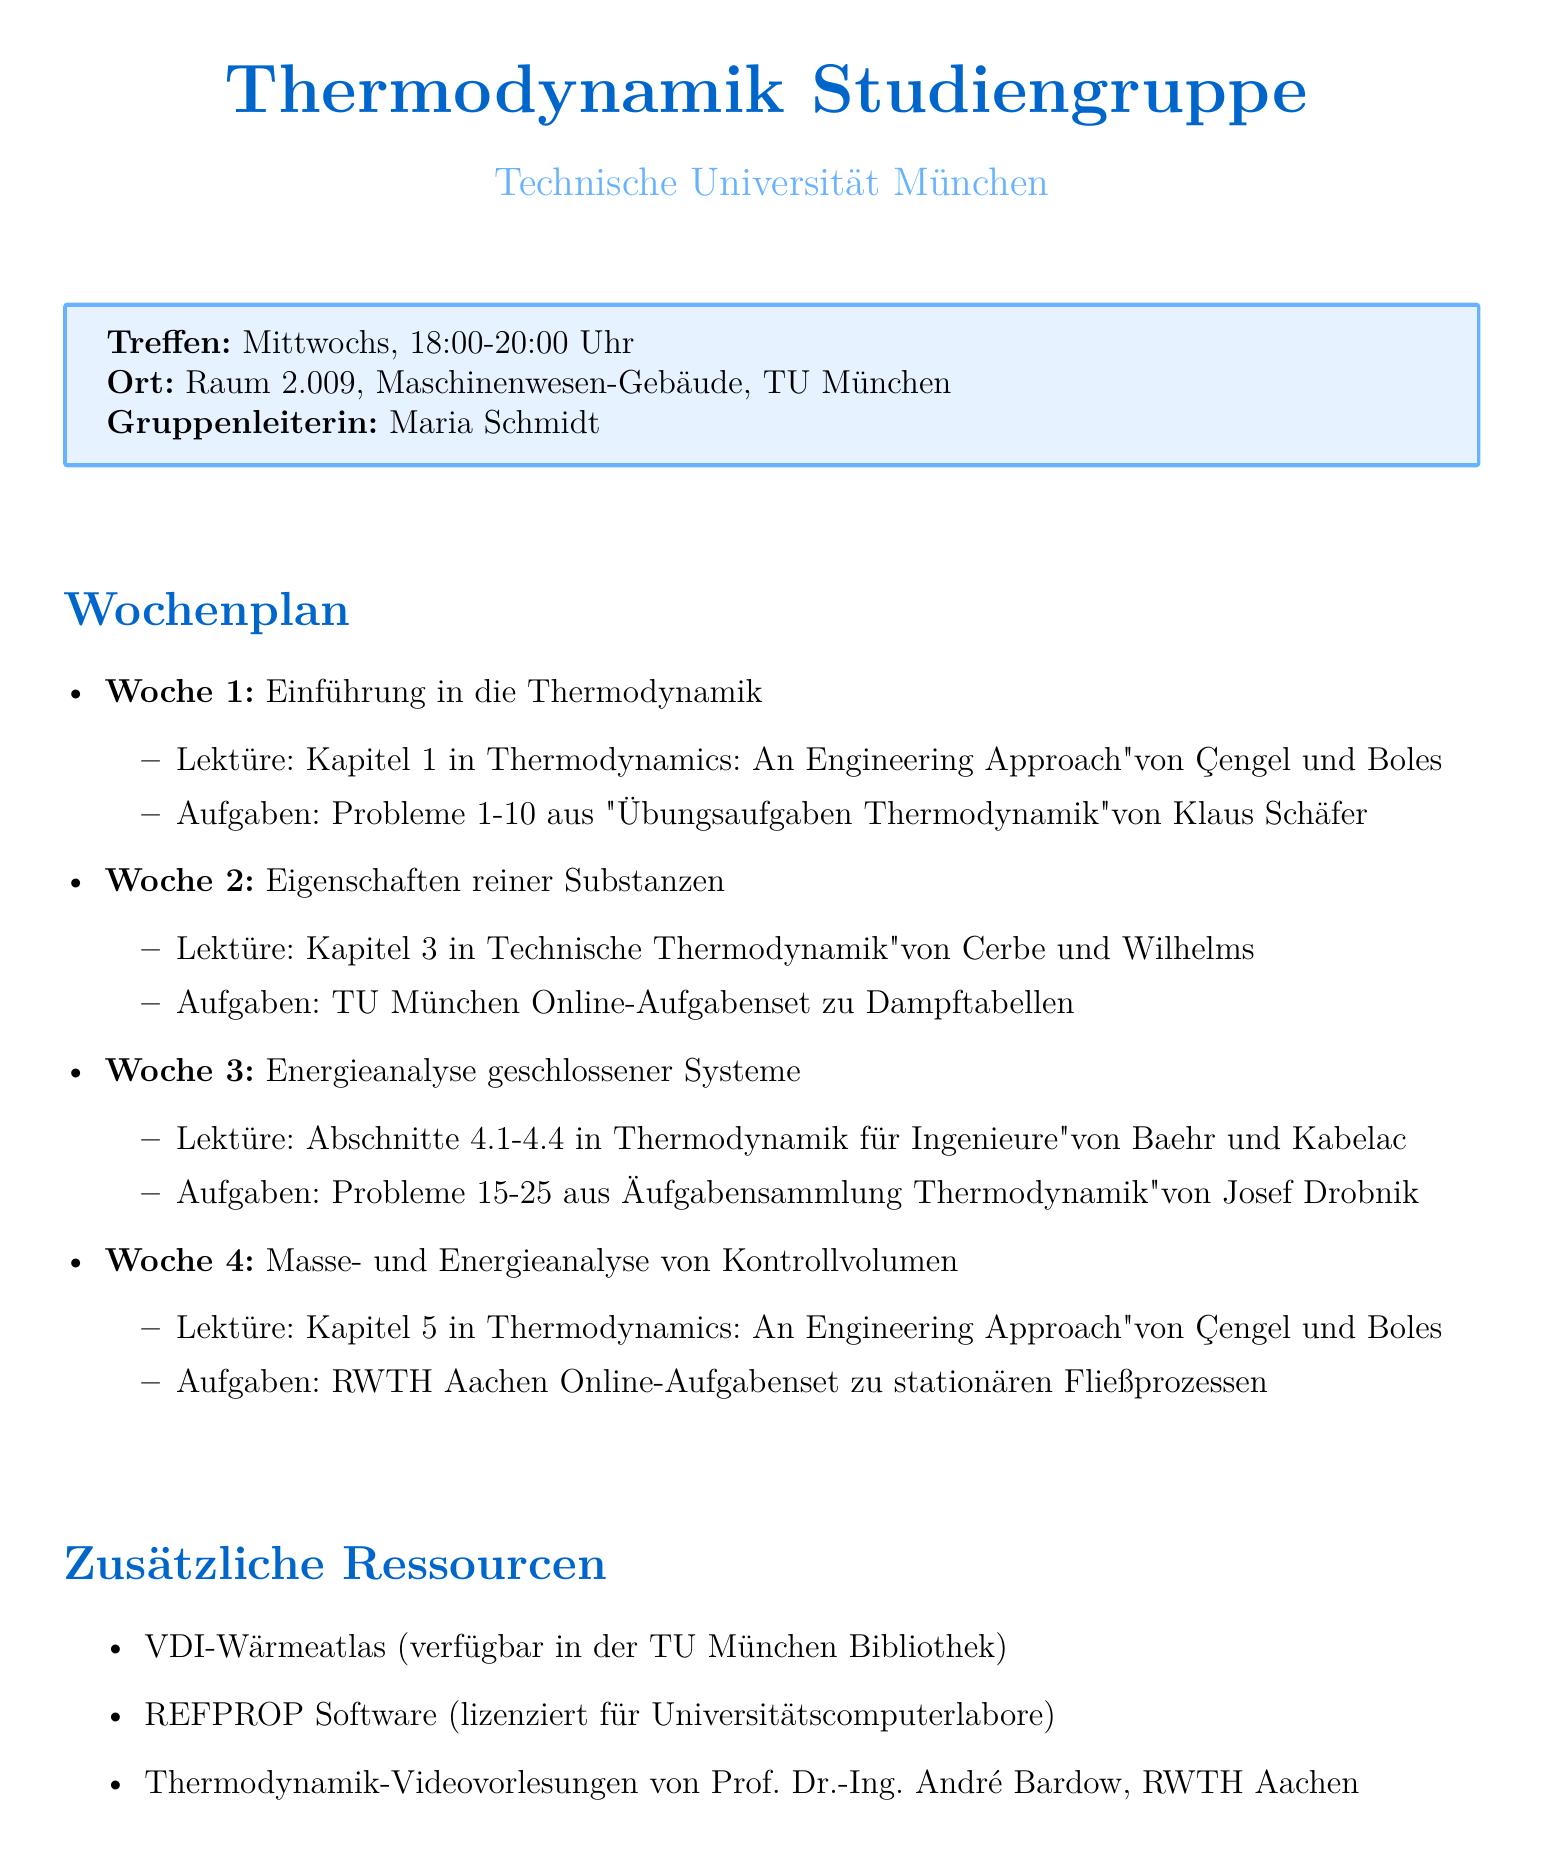What is the meeting time for the study group? The document specifies the meeting time as Wednesdays from 18:00 to 20:00.
Answer: Wednesdays, 18:00-20:00 Who is the group leader? The document lists Maria Schmidt as the group leader.
Answer: Maria Schmidt Which chapter is assigned for the first week? The reading for the first week includes Chapter 1 in "Thermodynamics: An Engineering Approach."
Answer: Chapter 1 What is the topic of the third week? The document states that the topic for the third week is "Energy Analysis of Closed Systems."
Answer: Energy Analysis of Closed Systems How many problems are assigned in the second week's problem set? The second week's problem set has challenges from TU Munich on steam tables but does not specify a number. However, the implied assignment includes problems related to steam tables.
Answer: Not specified What type of analysis is conducted in week 7? The document mentions that an exergy analysis of a refrigeration cycle will be conducted in week 7.
Answer: Exergy analysis What additional resource is available in the TU Munich library? The VDI-Wärmeatlas is identified as a comprehensive reference available in the library.
Answer: VDI-Wärmeatlas What is the location of the study group meetings? The document states the location as Room 2.009, Mechanical Engineering Building, TU Munich.
Answer: Room 2.009, Mechanical Engineering Building, TU Munich Which problems are assigned for week 5? Problems 30-40 from "Übungsaufgaben Thermodynamik" by Klaus Schäfer are assigned for week 5.
Answer: Problems 30-40 